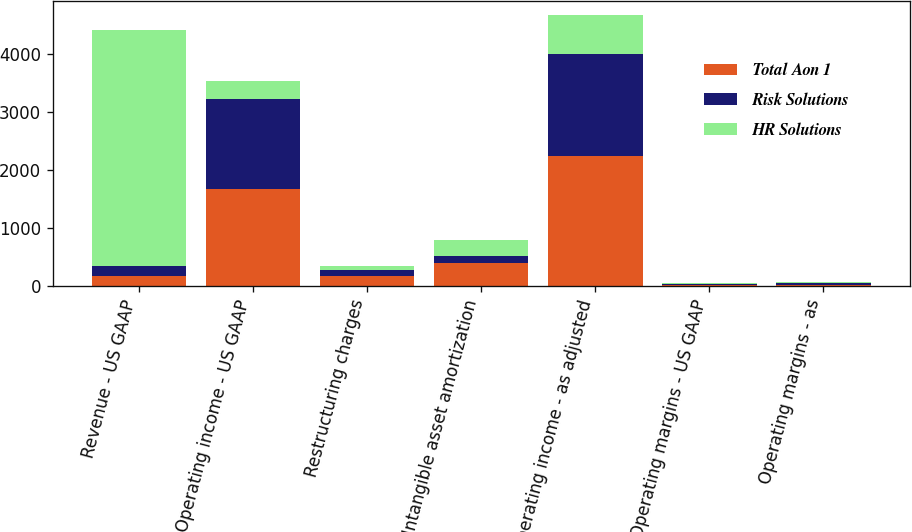<chart> <loc_0><loc_0><loc_500><loc_500><stacked_bar_chart><ecel><fcel>Revenue - US GAAP<fcel>Operating income - US GAAP<fcel>Restructuring charges<fcel>Intangible asset amortization<fcel>Operating income - as adjusted<fcel>Operating margins - US GAAP<fcel>Operating margins - as<nl><fcel>Total Aon 1<fcel>174<fcel>1671<fcel>174<fcel>395<fcel>2245<fcel>14.1<fcel>19<nl><fcel>Risk Solutions<fcel>174<fcel>1540<fcel>94<fcel>115<fcel>1749<fcel>19.8<fcel>22.5<nl><fcel>HR Solutions<fcel>4057<fcel>318<fcel>80<fcel>280<fcel>678<fcel>7.8<fcel>16.7<nl></chart> 